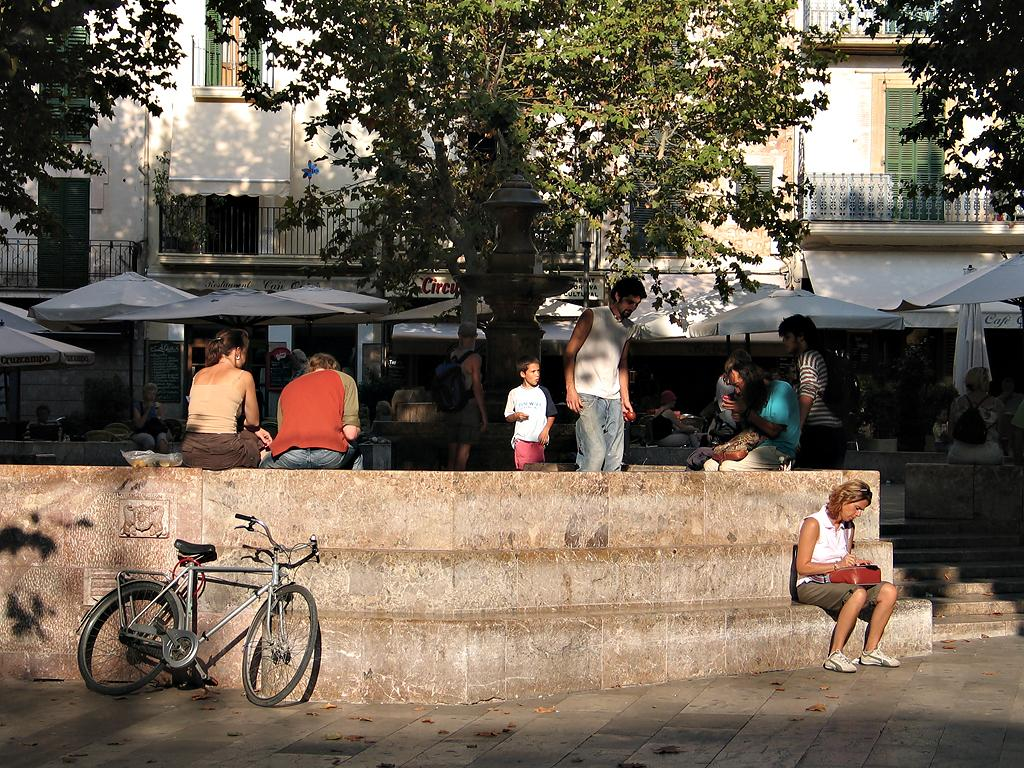What can be seen on the left side of the image? There is a bicycle on the left side of the image. Who or what is visible in the image? There are people visible in the image. What can be seen in the distance in the image? There are trees and buildings in the background of the image. What type of humor can be seen in the image? There is no humor present in the image; it features a bicycle, people, trees, and buildings. 